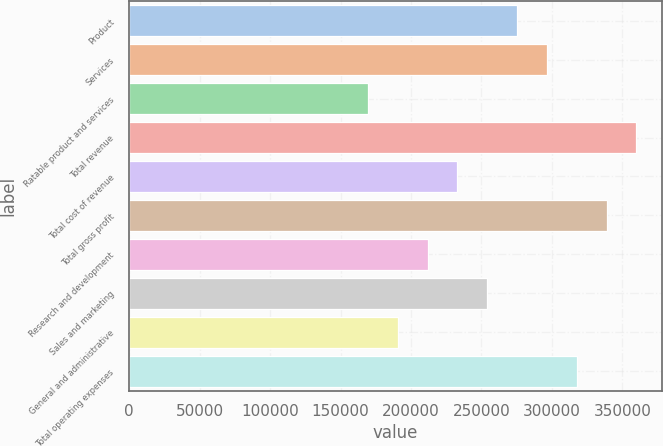<chart> <loc_0><loc_0><loc_500><loc_500><bar_chart><fcel>Product<fcel>Services<fcel>Ratable product and services<fcel>Total revenue<fcel>Total cost of revenue<fcel>Total gross profit<fcel>Research and development<fcel>Sales and marketing<fcel>General and administrative<fcel>Total operating expenses<nl><fcel>275328<fcel>296507<fcel>169433<fcel>360045<fcel>232970<fcel>338866<fcel>211791<fcel>254149<fcel>190612<fcel>317687<nl></chart> 